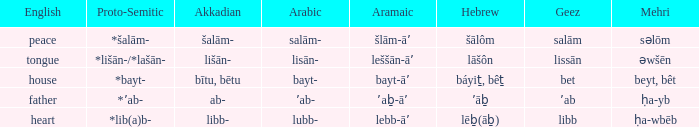If in arabic it is salām-, what is it in proto-semitic? *šalām-. 